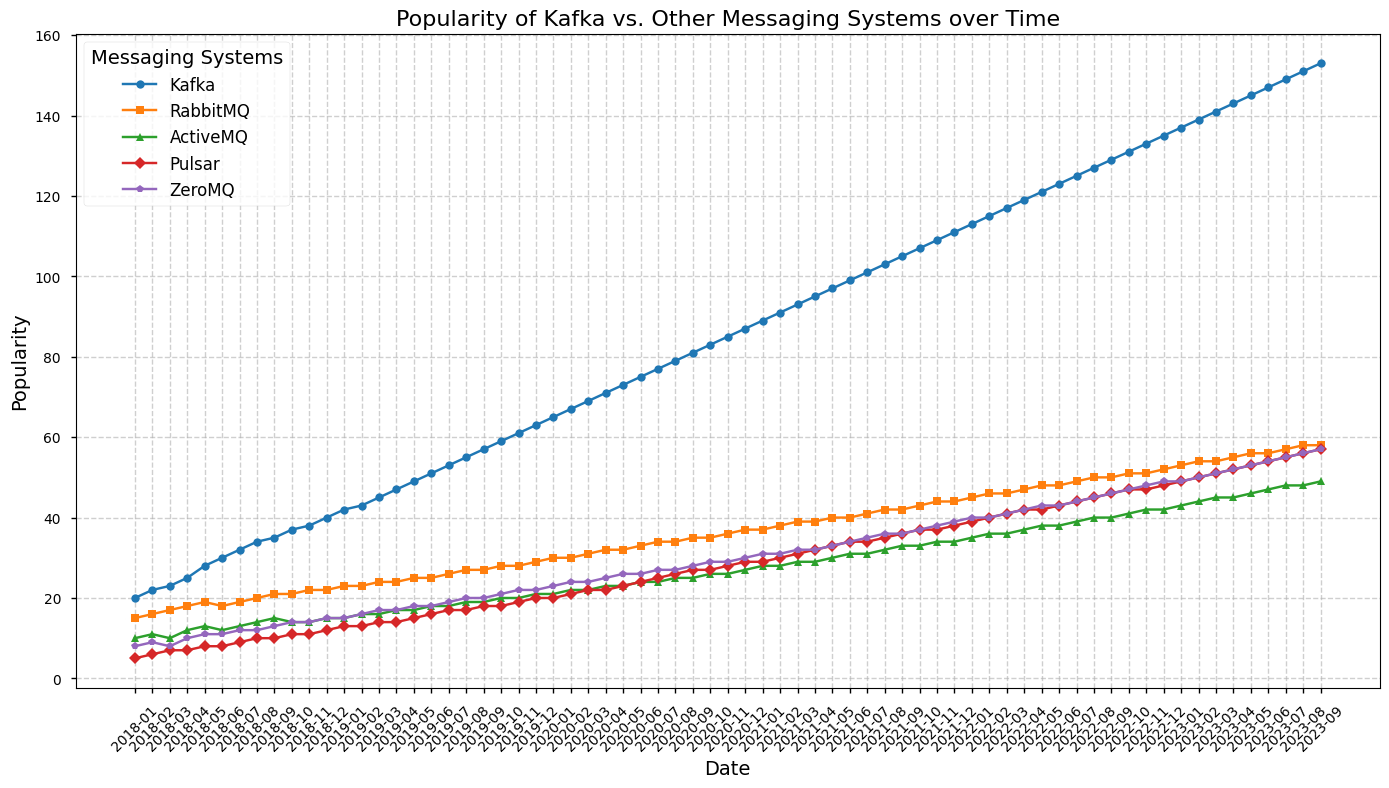What is the overall trend of Kafka's popularity from 2018 to 2023? Kafka's popularity shows a consistent upward trend from January 2018 to September 2023 without any periods of decline. This is evident from the progressively increasing line representing Kafka in the plot.
Answer: Increasing Which messaging system shows the least popularity growth from 2018 to 2023? By comparing the end values for each messaging system, ZeroMQ shows the least growth in popularity, starting around 8 and ending near 57. Other systems like Kafka, RabbitMQ, and Pulsar have higher ending values.
Answer: ZeroMQ In December 2018, what is the popularity difference between Kafka and RabbitMQ? By examining the plot for December 2018, Kafka's popularity is around 40, while RabbitMQ's is around 22. The difference between them is 40 - 22 = 18.
Answer: 18 How does the popularity of ActiveMQ compare to Pulsar in 2023? Throughout the year 2023, the plot shows that ActiveMQ's popularity remains consistently below Pulsar's. For example, in September 2023, ActiveMQ's popularity is about 49 while Pulsar's is around 57.
Answer: Less than Between RabbitMQ and Pulsar, which system had a steeper increase in popularity from 2018 to 2023? Eventhough both systems show growth over the years, Pulsar seems to have an overall steeper increase. This is clear from the line for Pulsar, which has a more pronounced slope upward in comparison to RabbitMQ's relatively flatter slope.
Answer: Pulsar What is the general shape or pattern of the popularity growth of ZeroMQ over the years? ZeroMQ's popularity shows gradual but steady growth without significant spikes or drops, generally forming a slowly rising curve from 8 to about 57 from 2018 to 2023.
Answer: Gradual increase Did any messaging system become less popular during the time period covered by the plot? By looking at the trend lines for all messaging systems, none of the systems show a decrease in popularity; they all have either a steady or increasing trend.
Answer: No How much did Kafka's popularity increase from January 2018 to January 2019? In January 2018, Kafka's popularity was around 20. By January 2019, it increased to about 42. The increase is thus 42 - 20 = 22.
Answer: 22 Between June 2019 and December 2019, did any messaging system show a decrease in popularity? By examining the lines for all systems between June 2019 and December 2019, it appears that ActiveMQ's popularity remained stable and RabbitMQ's popularity remained stable as well. None of the lines show a downward slope in this period.
Answer: No Comparing the starting and ending points in the plot, which messaging system had the highest absolute increase in popularity? By looking at the start and end points of each line, Kafka achieves the highest absolute increase, starting around 20 in January 2018 and reaching about 153 by September 2023, making the increase approximately 133.
Answer: Kafka 